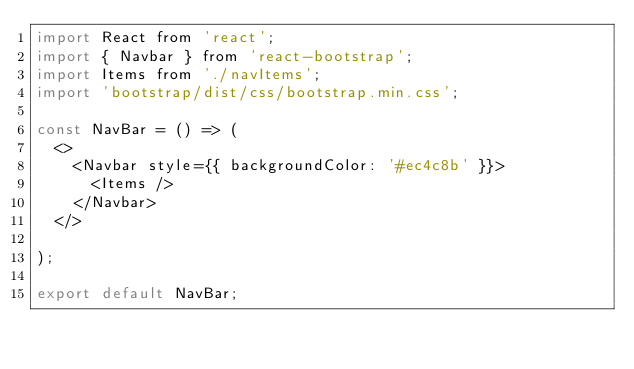Convert code to text. <code><loc_0><loc_0><loc_500><loc_500><_JavaScript_>import React from 'react';
import { Navbar } from 'react-bootstrap';
import Items from './navItems';
import 'bootstrap/dist/css/bootstrap.min.css';

const NavBar = () => (
  <>
    <Navbar style={{ backgroundColor: '#ec4c8b' }}>
      <Items />
    </Navbar>
  </>

);

export default NavBar;
</code> 